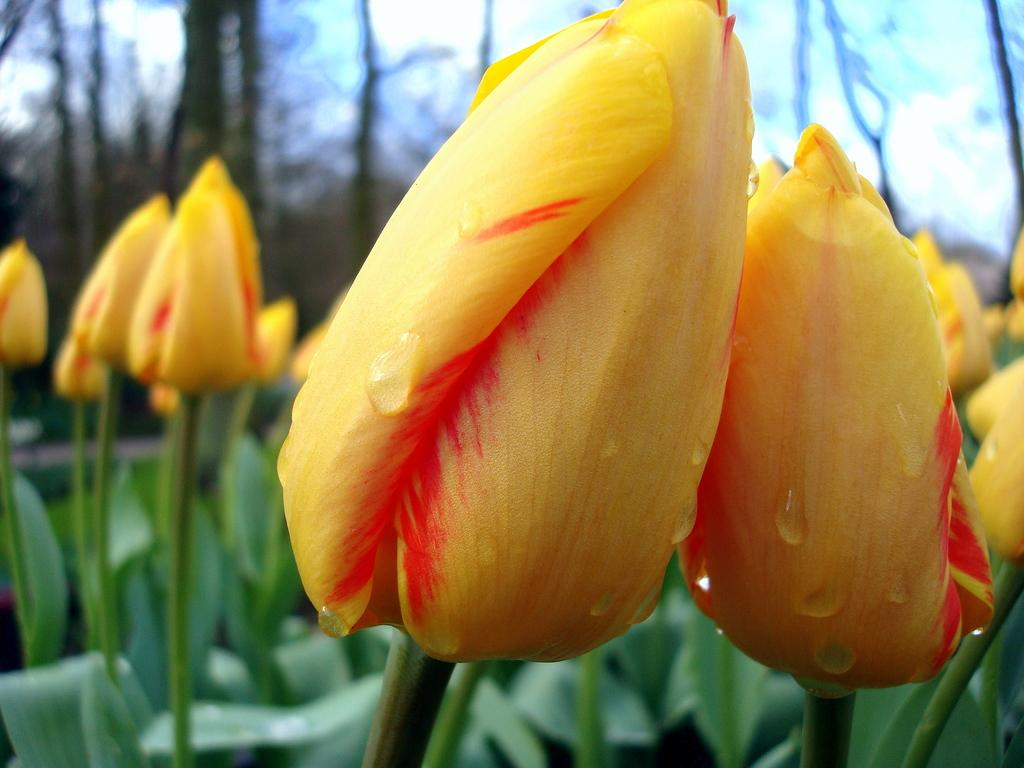What types of flowers are present in the image? There are flowers in yellow and orange colors in the image. What color are the leaves in the image? The leaves in the image are green. What can be seen in the background of the image? The background of the image is the sky. What is the color of the sky in the image? The color of the sky in the image is white. What type of lettuce is being used as a quill to write a letter in the image? There is no lettuce or writing activity present in the image; it features flowers and leaves with a white sky background. 